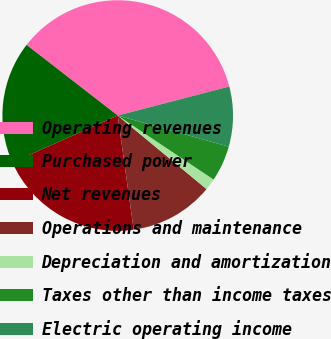<chart> <loc_0><loc_0><loc_500><loc_500><pie_chart><fcel>Operating revenues<fcel>Purchased power<fcel>Net revenues<fcel>Operations and maintenance<fcel>Depreciation and amortization<fcel>Taxes other than income taxes<fcel>Electric operating income<nl><fcel>35.45%<fcel>17.16%<fcel>20.54%<fcel>11.78%<fcel>1.64%<fcel>5.02%<fcel>8.4%<nl></chart> 